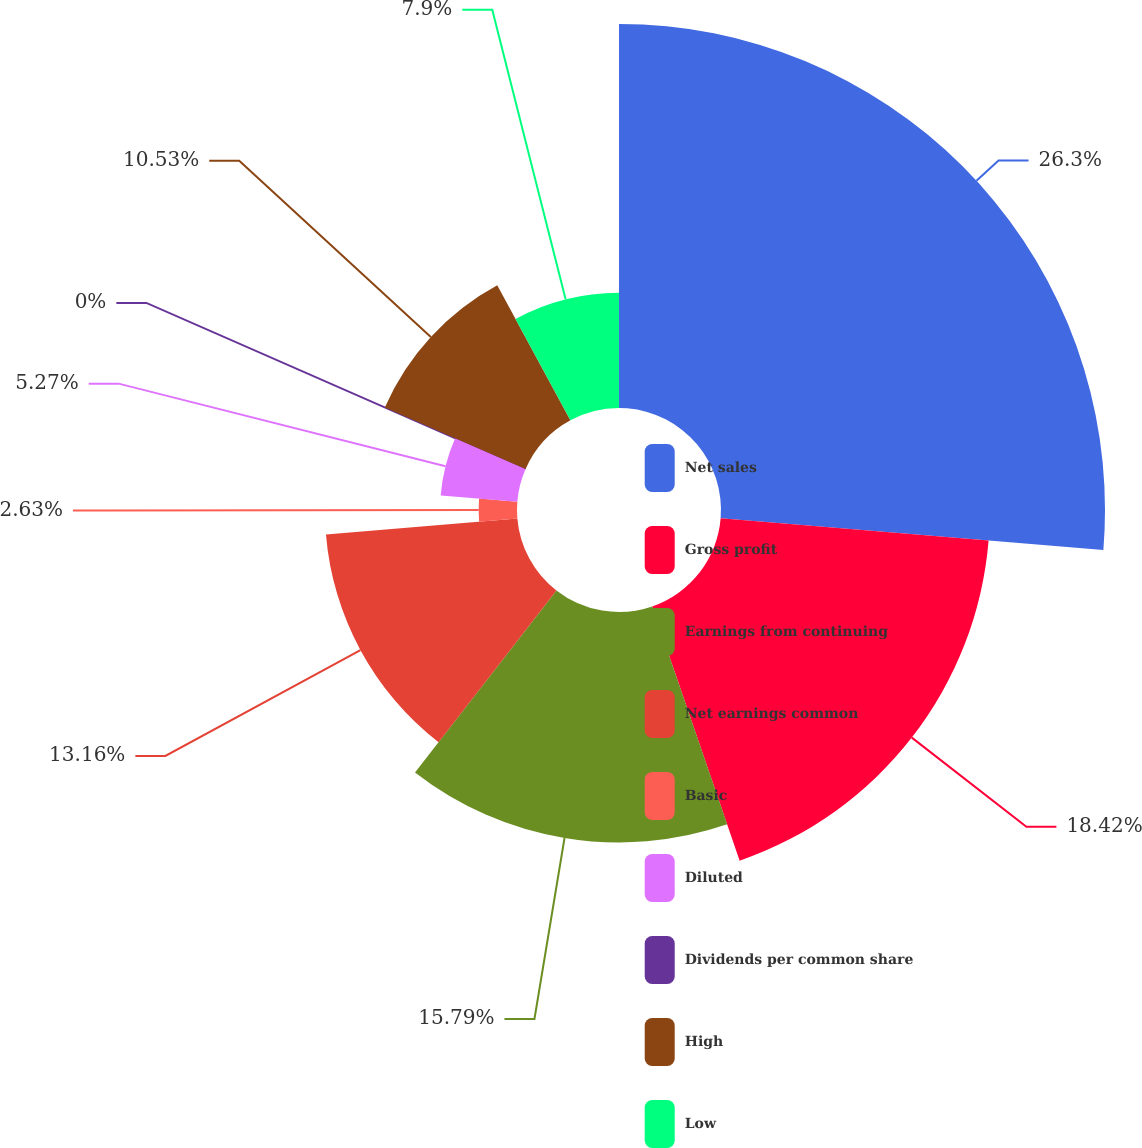Convert chart to OTSL. <chart><loc_0><loc_0><loc_500><loc_500><pie_chart><fcel>Net sales<fcel>Gross profit<fcel>Earnings from continuing<fcel>Net earnings common<fcel>Basic<fcel>Diluted<fcel>Dividends per common share<fcel>High<fcel>Low<nl><fcel>26.31%<fcel>18.42%<fcel>15.79%<fcel>13.16%<fcel>2.63%<fcel>5.27%<fcel>0.0%<fcel>10.53%<fcel>7.9%<nl></chart> 